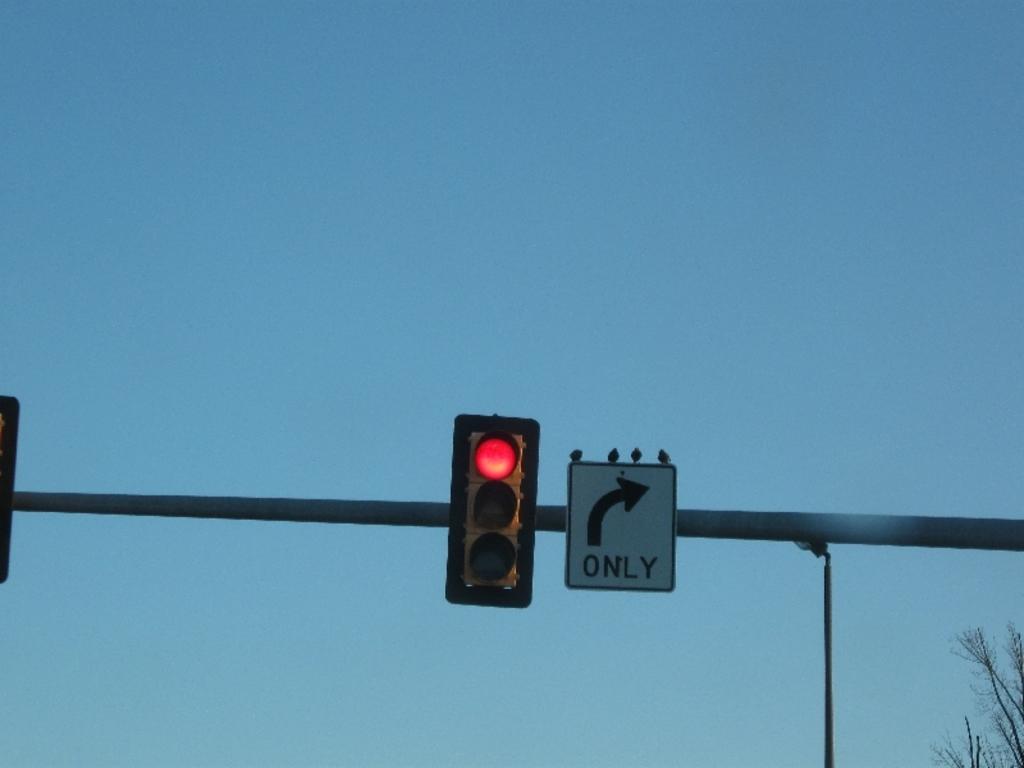What type of turn is only permitted?
Provide a succinct answer. Right. What does the sign say?
Keep it short and to the point. Only. 